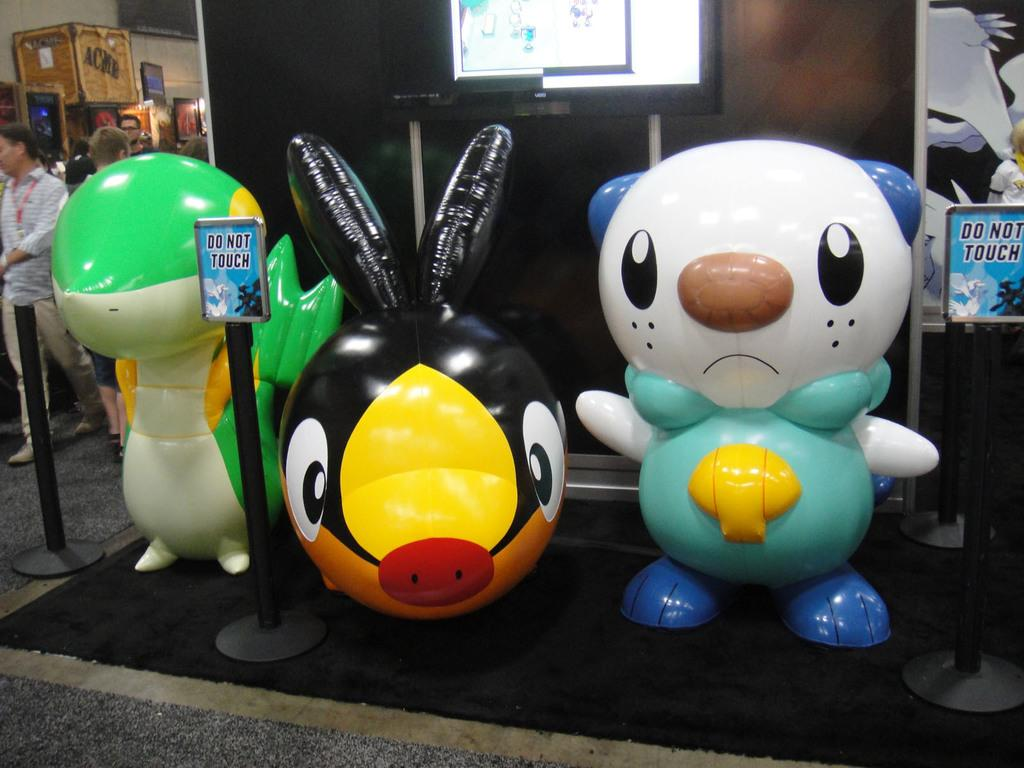What type of objects can be seen in the image? There are toys and boards with poles in the image. What electronic device is present in the image? There is a television in the image. Can you describe the gathering of people in the image? There is a group of people standing on a carpet in the image. How many apples are being held by the cows in the image? There are no cows or apples present in the image. 